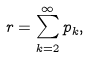Convert formula to latex. <formula><loc_0><loc_0><loc_500><loc_500>{ r } = \sum _ { k = 2 } ^ { \infty } { p } _ { k } ,</formula> 